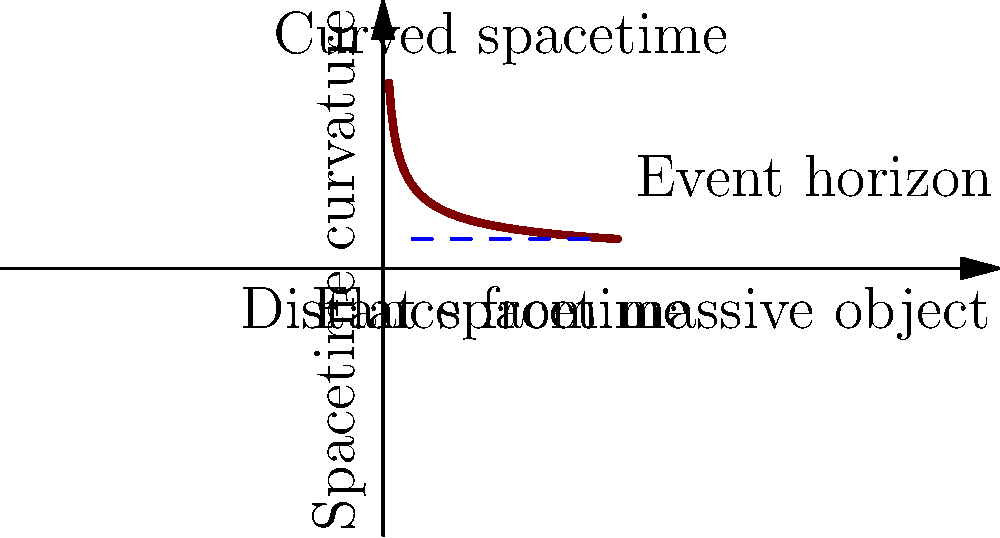In the abstract representation of spacetime curvature near a massive object, what does the asymptotic behavior of the curve as it approaches the y-axis signify in terms of the object's gravitational influence? To understand the significance of the curve's asymptotic behavior:

1. Observe that the x-axis represents distance from the massive object, while the y-axis represents spacetime curvature.

2. As we move from right to left (approaching the massive object):
   a) The curve becomes steeper, indicating increased spacetime curvature.
   b) Near the y-axis, the curve approaches infinity.

3. This asymptotic behavior implies:
   a) Extremely strong gravitational effects very close to the object.
   b) Potential formation of an event horizon, where spacetime is so curved that even light cannot escape.

4. The blue dashed line represents a conceptual event horizon.

5. Beyond the event horizon (closer to the massive object), classical physics breaks down, and quantum effects become significant.

6. This abstraction visualizes Einstein's concept of gravity as geometry, where mass curves spacetime itself.
Answer: Infinite spacetime curvature at the object's surface, indicating extreme gravitational effects and potential event horizon formation. 